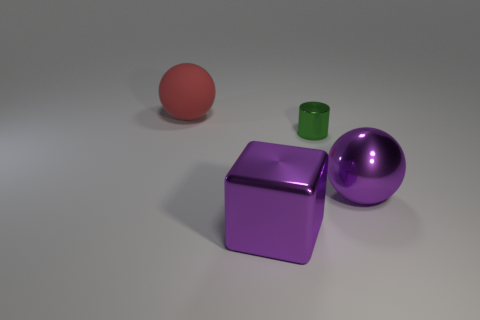Add 1 purple metallic blocks. How many objects exist? 5 Subtract all cylinders. How many objects are left? 3 Add 4 purple objects. How many purple objects are left? 6 Add 4 small blue metallic cylinders. How many small blue metallic cylinders exist? 4 Subtract 0 cyan blocks. How many objects are left? 4 Subtract all purple cylinders. Subtract all big red objects. How many objects are left? 3 